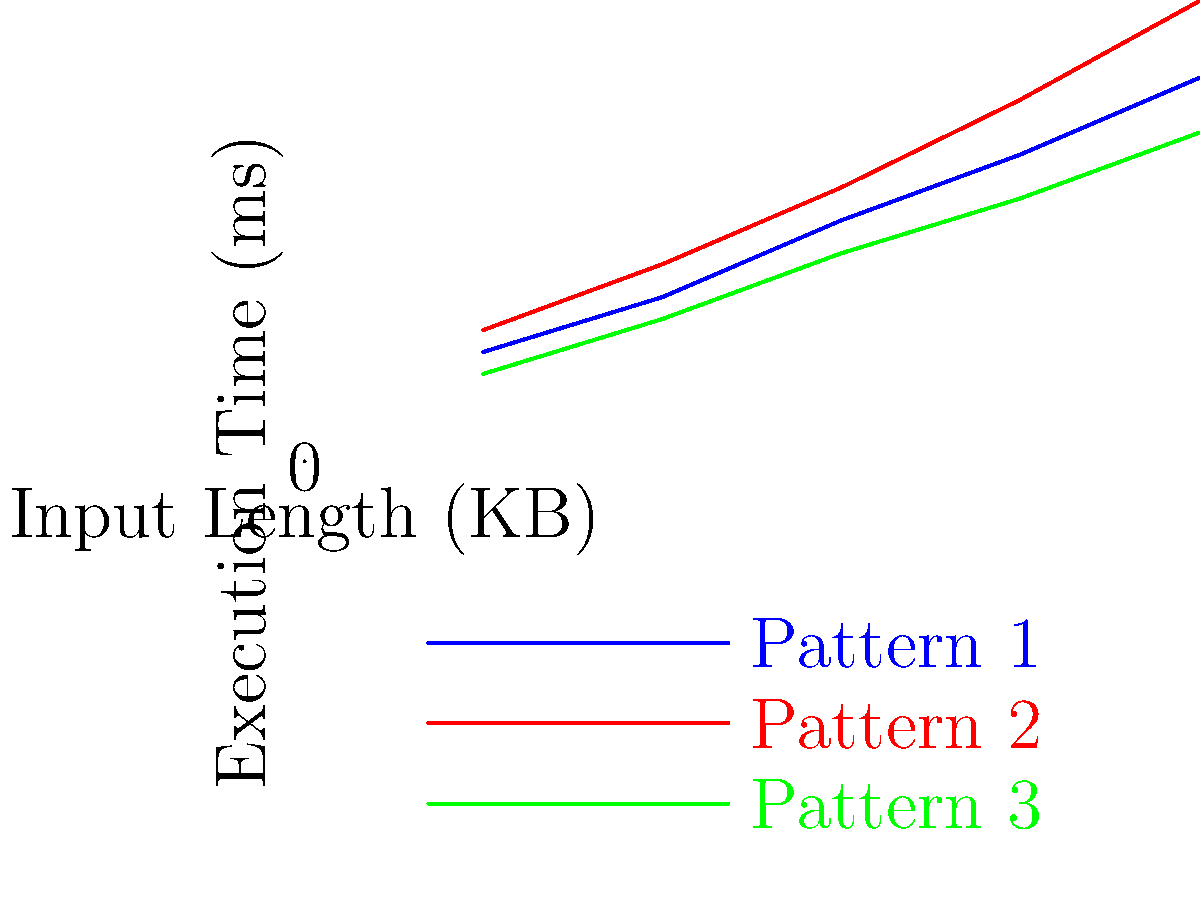Given the line graph showing the performance of three different regex patterns (Pattern 1, Pattern 2, and Pattern 3) for varying input lengths, which pattern consistently demonstrates the best performance across all input sizes? Explain your reasoning based on the graph. To determine which regex pattern consistently demonstrates the best performance, we need to analyze the execution times for each pattern across all input sizes. Let's break it down step-by-step:

1. Understand the graph:
   - X-axis represents Input Length in KB
   - Y-axis represents Execution Time in milliseconds
   - Lower execution time indicates better performance

2. Analyze each pattern:
   - Pattern 1 (Blue line): Starts at 10ms for 1KB and increases to 35ms for 5KB
   - Pattern 2 (Red line): Starts at 12ms for 1KB and increases to 42ms for 5KB
   - Pattern 3 (Green line): Starts at 8ms for 1KB and increases to 30ms for 5KB

3. Compare the patterns:
   - Pattern 3 has the lowest execution time at every input size
   - Pattern 1 is consistently in the middle
   - Pattern 2 has the highest execution time at every input size

4. Consistency check:
   - Pattern 3's line remains below the other two lines throughout the graph
   - The relative positions of the lines do not change or intersect

5. Conclusion:
   Pattern 3 (Green line) consistently demonstrates the best performance across all input sizes because it has the lowest execution time for every input length from 1KB to 5KB.
Answer: Pattern 3 